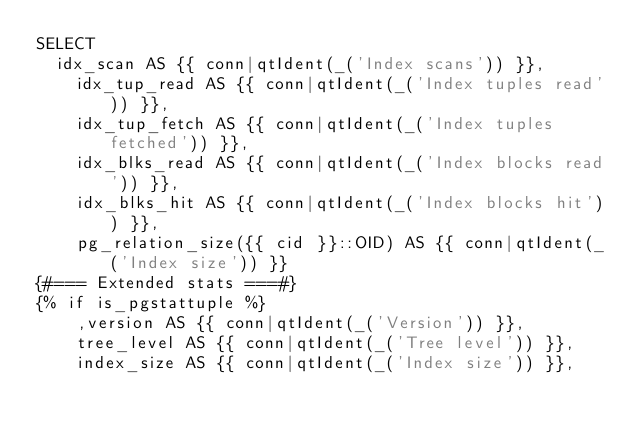Convert code to text. <code><loc_0><loc_0><loc_500><loc_500><_SQL_>SELECT
  idx_scan AS {{ conn|qtIdent(_('Index scans')) }},
    idx_tup_read AS {{ conn|qtIdent(_('Index tuples read')) }},
    idx_tup_fetch AS {{ conn|qtIdent(_('Index tuples fetched')) }},
    idx_blks_read AS {{ conn|qtIdent(_('Index blocks read')) }},
    idx_blks_hit AS {{ conn|qtIdent(_('Index blocks hit')) }},
    pg_relation_size({{ cid }}::OID) AS {{ conn|qtIdent(_('Index size')) }}
{#=== Extended stats ===#}
{% if is_pgstattuple %}
    ,version AS {{ conn|qtIdent(_('Version')) }},
    tree_level AS {{ conn|qtIdent(_('Tree level')) }},
    index_size AS {{ conn|qtIdent(_('Index size')) }},</code> 